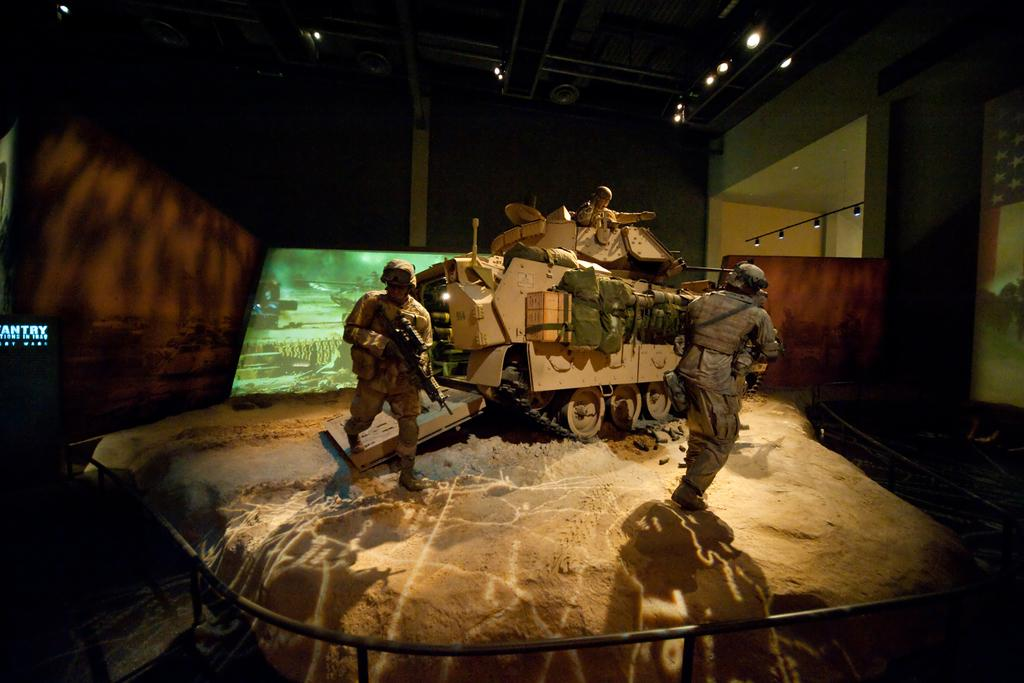How many people are in the image? There are two persons in the image. What else can be seen in the image besides the people? There is a vehicle, a screen, lights, and a wall in the image. What type of meal is being prepared on the screen in the image? There is no meal being prepared on the screen in the image; it is just a screen. Can you see a squirrel in the image? There is no squirrel present in the image. 